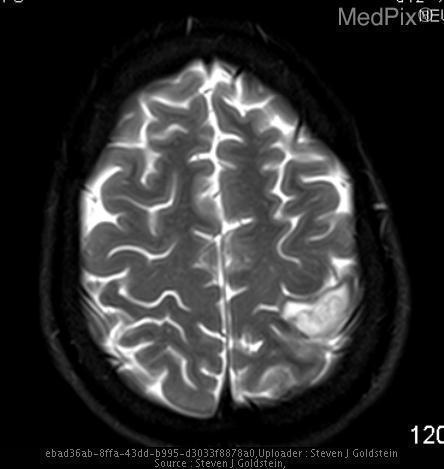Is this image abnormal?
Quick response, please. Yes. How do you know this is a t2 weighted image?
Write a very short answer. Csf is white. What tells you that the image is t2?
Answer briefly. White versus grey matter brightness. Does the lesion demonstrate ring enhancement?
Give a very brief answer. Yes. Is this lesion ring enhancing?
Concise answer only. Yes. Where is the lesion located?
Write a very short answer. Left parietal lobe. Which lobe is the lesion in?
Quick response, please. Left parietal lobe. 